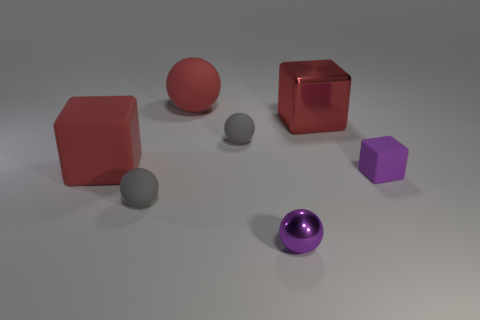Subtract 1 cubes. How many cubes are left? 2 Subtract all red balls. How many balls are left? 3 Subtract all tiny rubber cubes. How many cubes are left? 2 Subtract all green spheres. Subtract all gray blocks. How many spheres are left? 4 Add 2 gray balls. How many objects exist? 9 Subtract 1 purple balls. How many objects are left? 6 Subtract all spheres. How many objects are left? 3 Subtract all small balls. Subtract all tiny metal objects. How many objects are left? 3 Add 3 gray rubber objects. How many gray rubber objects are left? 5 Add 3 large blocks. How many large blocks exist? 5 